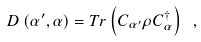<formula> <loc_0><loc_0><loc_500><loc_500>D \left ( \alpha ^ { \prime } , \alpha \right ) = T r \left ( C _ { \alpha ^ { \prime } } \rho C ^ { \dagger } _ { \alpha } \right ) \ ,</formula> 